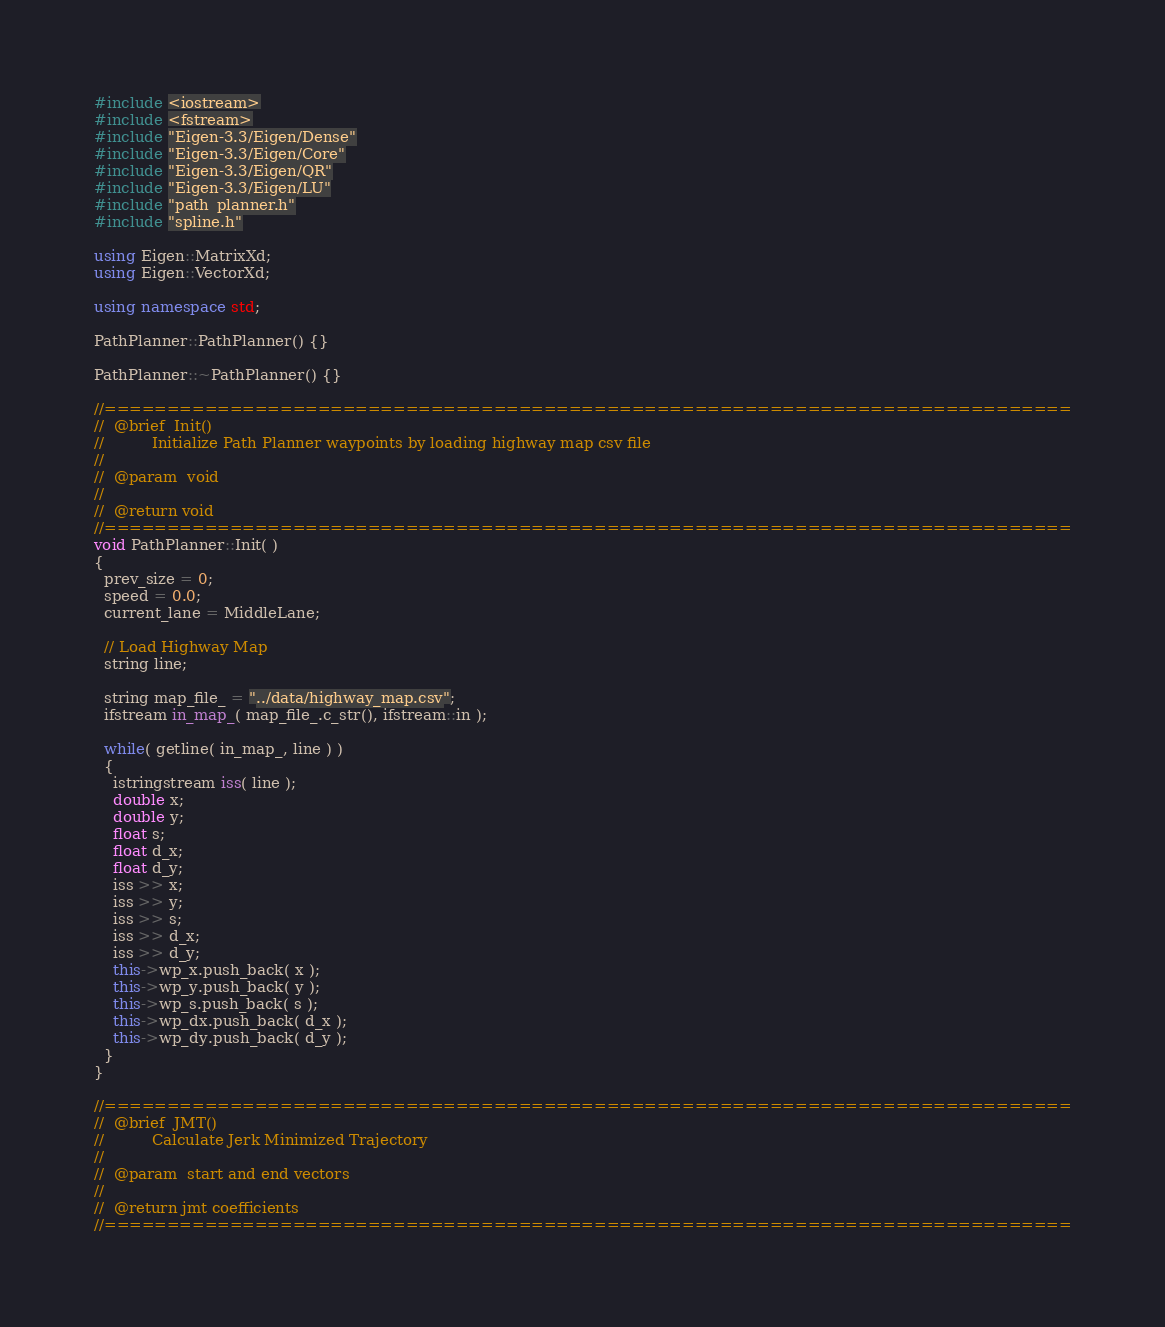<code> <loc_0><loc_0><loc_500><loc_500><_C++_>#include <iostream>
#include <fstream>
#include "Eigen-3.3/Eigen/Dense"
#include "Eigen-3.3/Eigen/Core"
#include "Eigen-3.3/Eigen/QR"
#include "Eigen-3.3/Eigen/LU"
#include "path_planner.h"
#include "spline.h"

using Eigen::MatrixXd;
using Eigen::VectorXd;

using namespace std;

PathPlanner::PathPlanner() {}

PathPlanner::~PathPlanner() {}

//=============================================================================
//  @brief  Init()
//          Initialize Path Planner waypoints by loading highway map csv file 
//
//  @param  void
//
//  @return void 
//=============================================================================
void PathPlanner::Init( ) 
{
  prev_size = 0;
  speed = 0.0;
  current_lane = MiddleLane;

  // Load Highway Map
  string line;
  
  string map_file_ = "../data/highway_map.csv";
  ifstream in_map_( map_file_.c_str(), ifstream::in );
  
  while( getline( in_map_, line ) ) 
  {
  	istringstream iss( line );
  	double x;
  	double y;
  	float s;
  	float d_x;
  	float d_y;
  	iss >> x;
  	iss >> y;
  	iss >> s;
  	iss >> d_x;
  	iss >> d_y;
  	this->wp_x.push_back( x );
  	this->wp_y.push_back( y );
  	this->wp_s.push_back( s );
  	this->wp_dx.push_back( d_x );
  	this->wp_dy.push_back( d_y );
  }
}

//=============================================================================
//  @brief  JMT()
//          Calculate Jerk Minimized Trajectory 
//
//  @param  start and end vectors 
//
//  @return jmt coefficients 
//=============================================================================</code> 